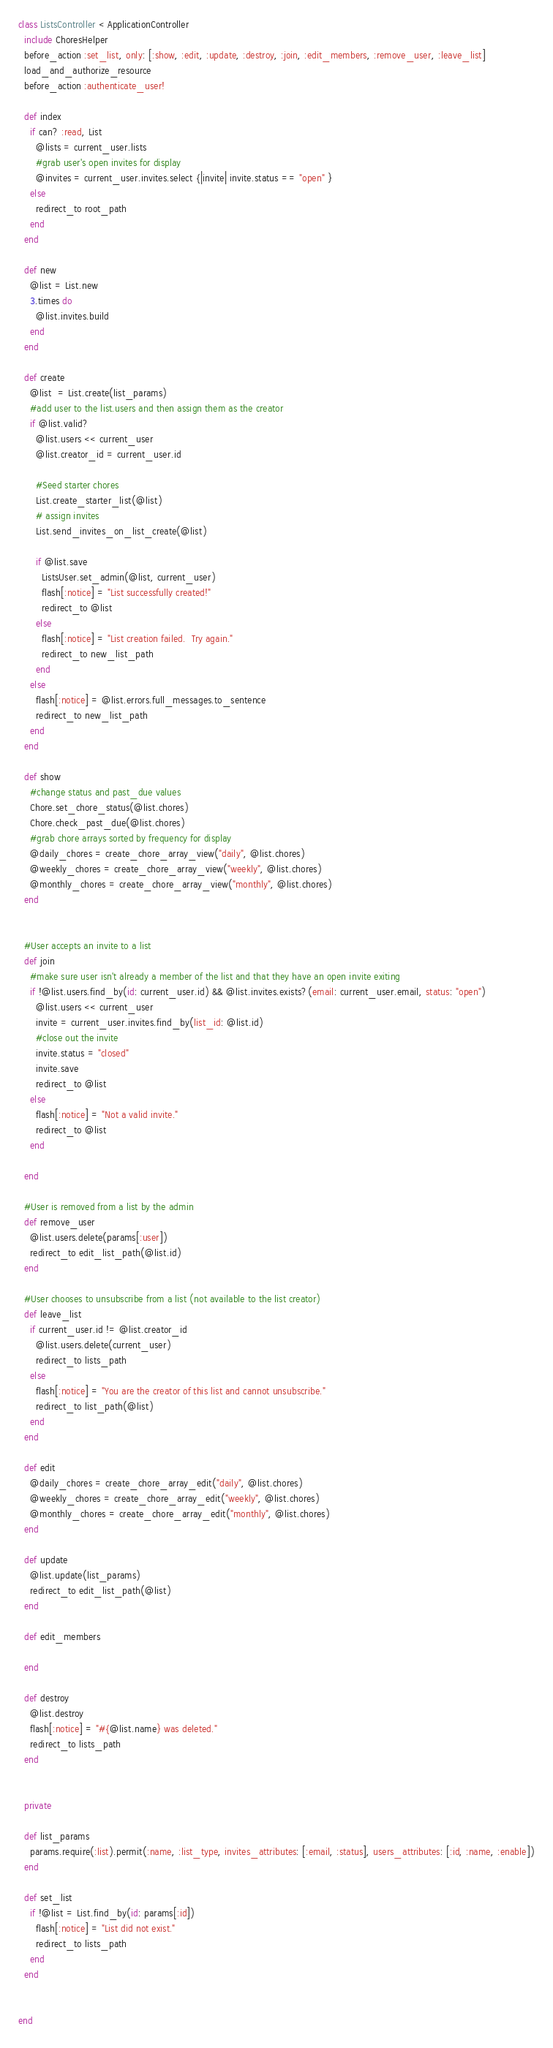Convert code to text. <code><loc_0><loc_0><loc_500><loc_500><_Ruby_>class ListsController < ApplicationController
  include ChoresHelper
  before_action :set_list, only: [:show, :edit, :update, :destroy, :join, :edit_members, :remove_user, :leave_list]
  load_and_authorize_resource
  before_action :authenticate_user!

  def index
    if can? :read, List
      @lists = current_user.lists
      #grab user's open invites for display
      @invites = current_user.invites.select {|invite| invite.status == "open" }
    else
      redirect_to root_path
    end
  end

  def new
    @list = List.new
    3.times do
      @list.invites.build
    end
  end

  def create
    @list  = List.create(list_params)
    #add user to the list.users and then assign them as the creator
    if @list.valid?
      @list.users << current_user
      @list.creator_id = current_user.id

      #Seed starter chores
      List.create_starter_list(@list)
      # assign invites
      List.send_invites_on_list_create(@list)

      if @list.save
        ListsUser.set_admin(@list, current_user)
        flash[:notice] = "List successfully created!"
        redirect_to @list
      else
        flash[:notice] = "List creation failed.  Try again."
        redirect_to new_list_path
      end
    else
      flash[:notice] = @list.errors.full_messages.to_sentence
      redirect_to new_list_path
    end
  end

  def show
    #change status and past_due values
    Chore.set_chore_status(@list.chores)
    Chore.check_past_due(@list.chores)
    #grab chore arrays sorted by frequency for display
    @daily_chores = create_chore_array_view("daily", @list.chores)
    @weekly_chores = create_chore_array_view("weekly", @list.chores)
    @monthly_chores = create_chore_array_view("monthly", @list.chores)
  end


  #User accepts an invite to a list
  def join
    #make sure user isn't already a member of the list and that they have an open invite exiting
    if !@list.users.find_by(id: current_user.id) && @list.invites.exists?(email: current_user.email, status: "open")
      @list.users << current_user
      invite = current_user.invites.find_by(list_id: @list.id)
      #close out the invite
      invite.status = "closed"
      invite.save
      redirect_to @list
    else
      flash[:notice] = "Not a valid invite."
      redirect_to @list
    end

  end

  #User is removed from a list by the admin
  def remove_user
    @list.users.delete(params[:user])
    redirect_to edit_list_path(@list.id)
  end

  #User chooses to unsubscribe from a list (not available to the list creator)
  def leave_list
    if current_user.id != @list.creator_id
      @list.users.delete(current_user)
      redirect_to lists_path
    else
      flash[:notice] = "You are the creator of this list and cannot unsubscribe."
      redirect_to list_path(@list)
    end
  end

  def edit
    @daily_chores = create_chore_array_edit("daily", @list.chores)
    @weekly_chores = create_chore_array_edit("weekly", @list.chores)
    @monthly_chores = create_chore_array_edit("monthly", @list.chores)
  end

  def update
    @list.update(list_params)
    redirect_to edit_list_path(@list)
  end

  def edit_members

  end

  def destroy
    @list.destroy
    flash[:notice] = "#{@list.name} was deleted."
    redirect_to lists_path
  end


  private

  def list_params
    params.require(:list).permit(:name, :list_type, invites_attributes: [:email, :status], users_attributes: [:id, :name, :enable])
  end

  def set_list
    if !@list = List.find_by(id: params[:id])
      flash[:notice] = "List did not exist."
      redirect_to lists_path
    end
  end


end
</code> 